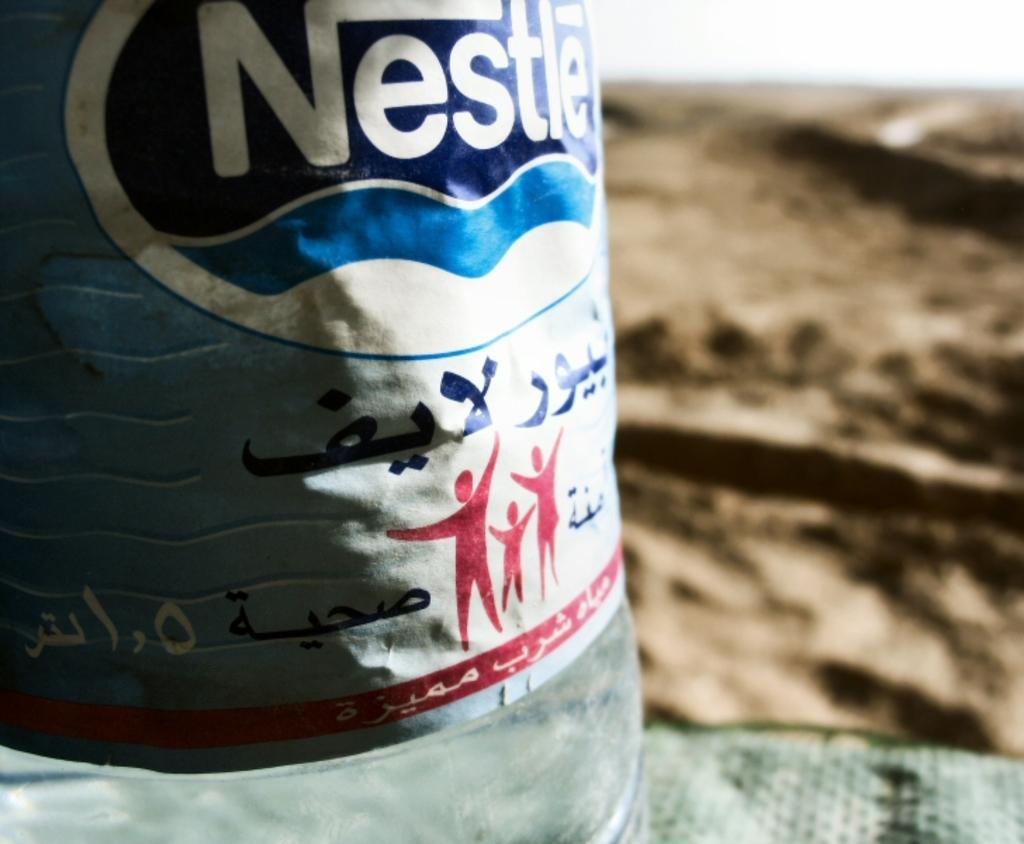What object is present in the image with a sticker on it? There is a bottle in the image with a sticker on it. What colors can be seen on the right side of the image? There is brown and green color on the right side of the image. What type of writing can be seen on the bottle in the image? There is no writing visible on the bottle in the image; only a sticker is present. Can you see any waves in the image? There are no waves present in the image. 